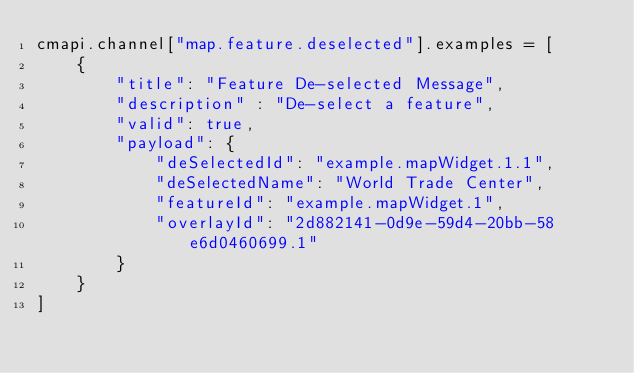<code> <loc_0><loc_0><loc_500><loc_500><_JavaScript_>cmapi.channel["map.feature.deselected"].examples = [
    {
        "title": "Feature De-selected Message",
        "description" : "De-select a feature",
        "valid": true,
        "payload": {
            "deSelectedId": "example.mapWidget.1.1", 
            "deSelectedName": "World Trade Center", 
            "featureId": "example.mapWidget.1", 
            "overlayId": "2d882141-0d9e-59d4-20bb-58e6d0460699.1"
        }
    }
]



</code> 